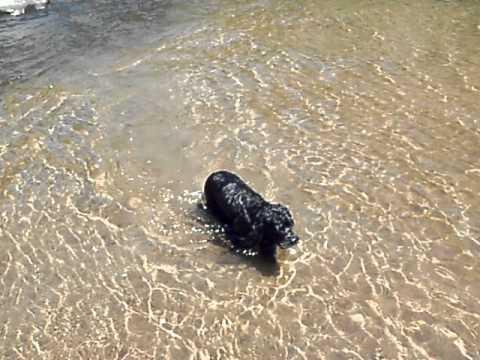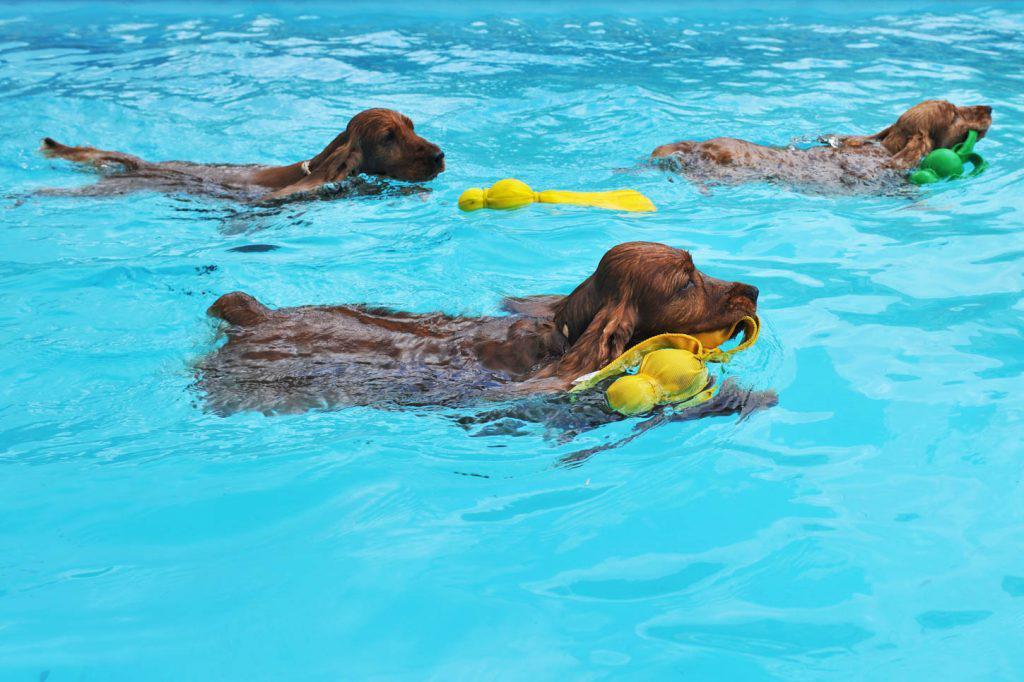The first image is the image on the left, the second image is the image on the right. Examine the images to the left and right. Is the description "In one of the images there are at least three dogs swimming" accurate? Answer yes or no. Yes. The first image is the image on the left, the second image is the image on the right. Assess this claim about the two images: "One image shows at least three spaniel dogs swimming horizontally in the same direction across a swimming pool.". Correct or not? Answer yes or no. Yes. 